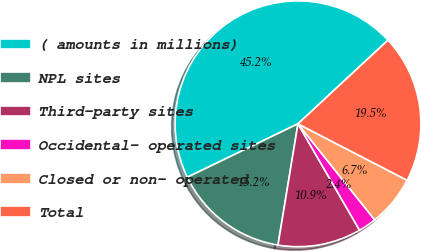Convert chart. <chart><loc_0><loc_0><loc_500><loc_500><pie_chart><fcel>( amounts in millions)<fcel>NPL sites<fcel>Third-party sites<fcel>Occidental- operated sites<fcel>Closed or non- operated<fcel>Total<nl><fcel>45.24%<fcel>15.24%<fcel>10.95%<fcel>2.38%<fcel>6.67%<fcel>19.52%<nl></chart> 